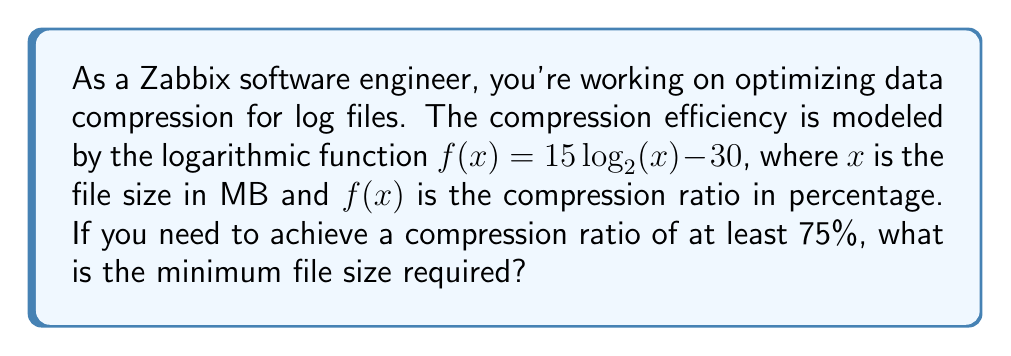Show me your answer to this math problem. To solve this problem, we need to follow these steps:

1) We're given the function $f(x) = 15 \log_2(x) - 30$, where $f(x)$ represents the compression ratio.

2) We need to find $x$ when $f(x) \geq 75$. So, let's set up the inequality:

   $15 \log_2(x) - 30 \geq 75$

3) Add 30 to both sides:

   $15 \log_2(x) \geq 105$

4) Divide both sides by 15:

   $\log_2(x) \geq 7$

5) To solve for $x$, we need to apply the inverse function (exponential) to both sides:

   $2^{\log_2(x)} \geq 2^7$

6) The left side simplifies to $x$:

   $x \geq 2^7 = 128$

Therefore, the minimum file size required is 128 MB.
Answer: 128 MB 